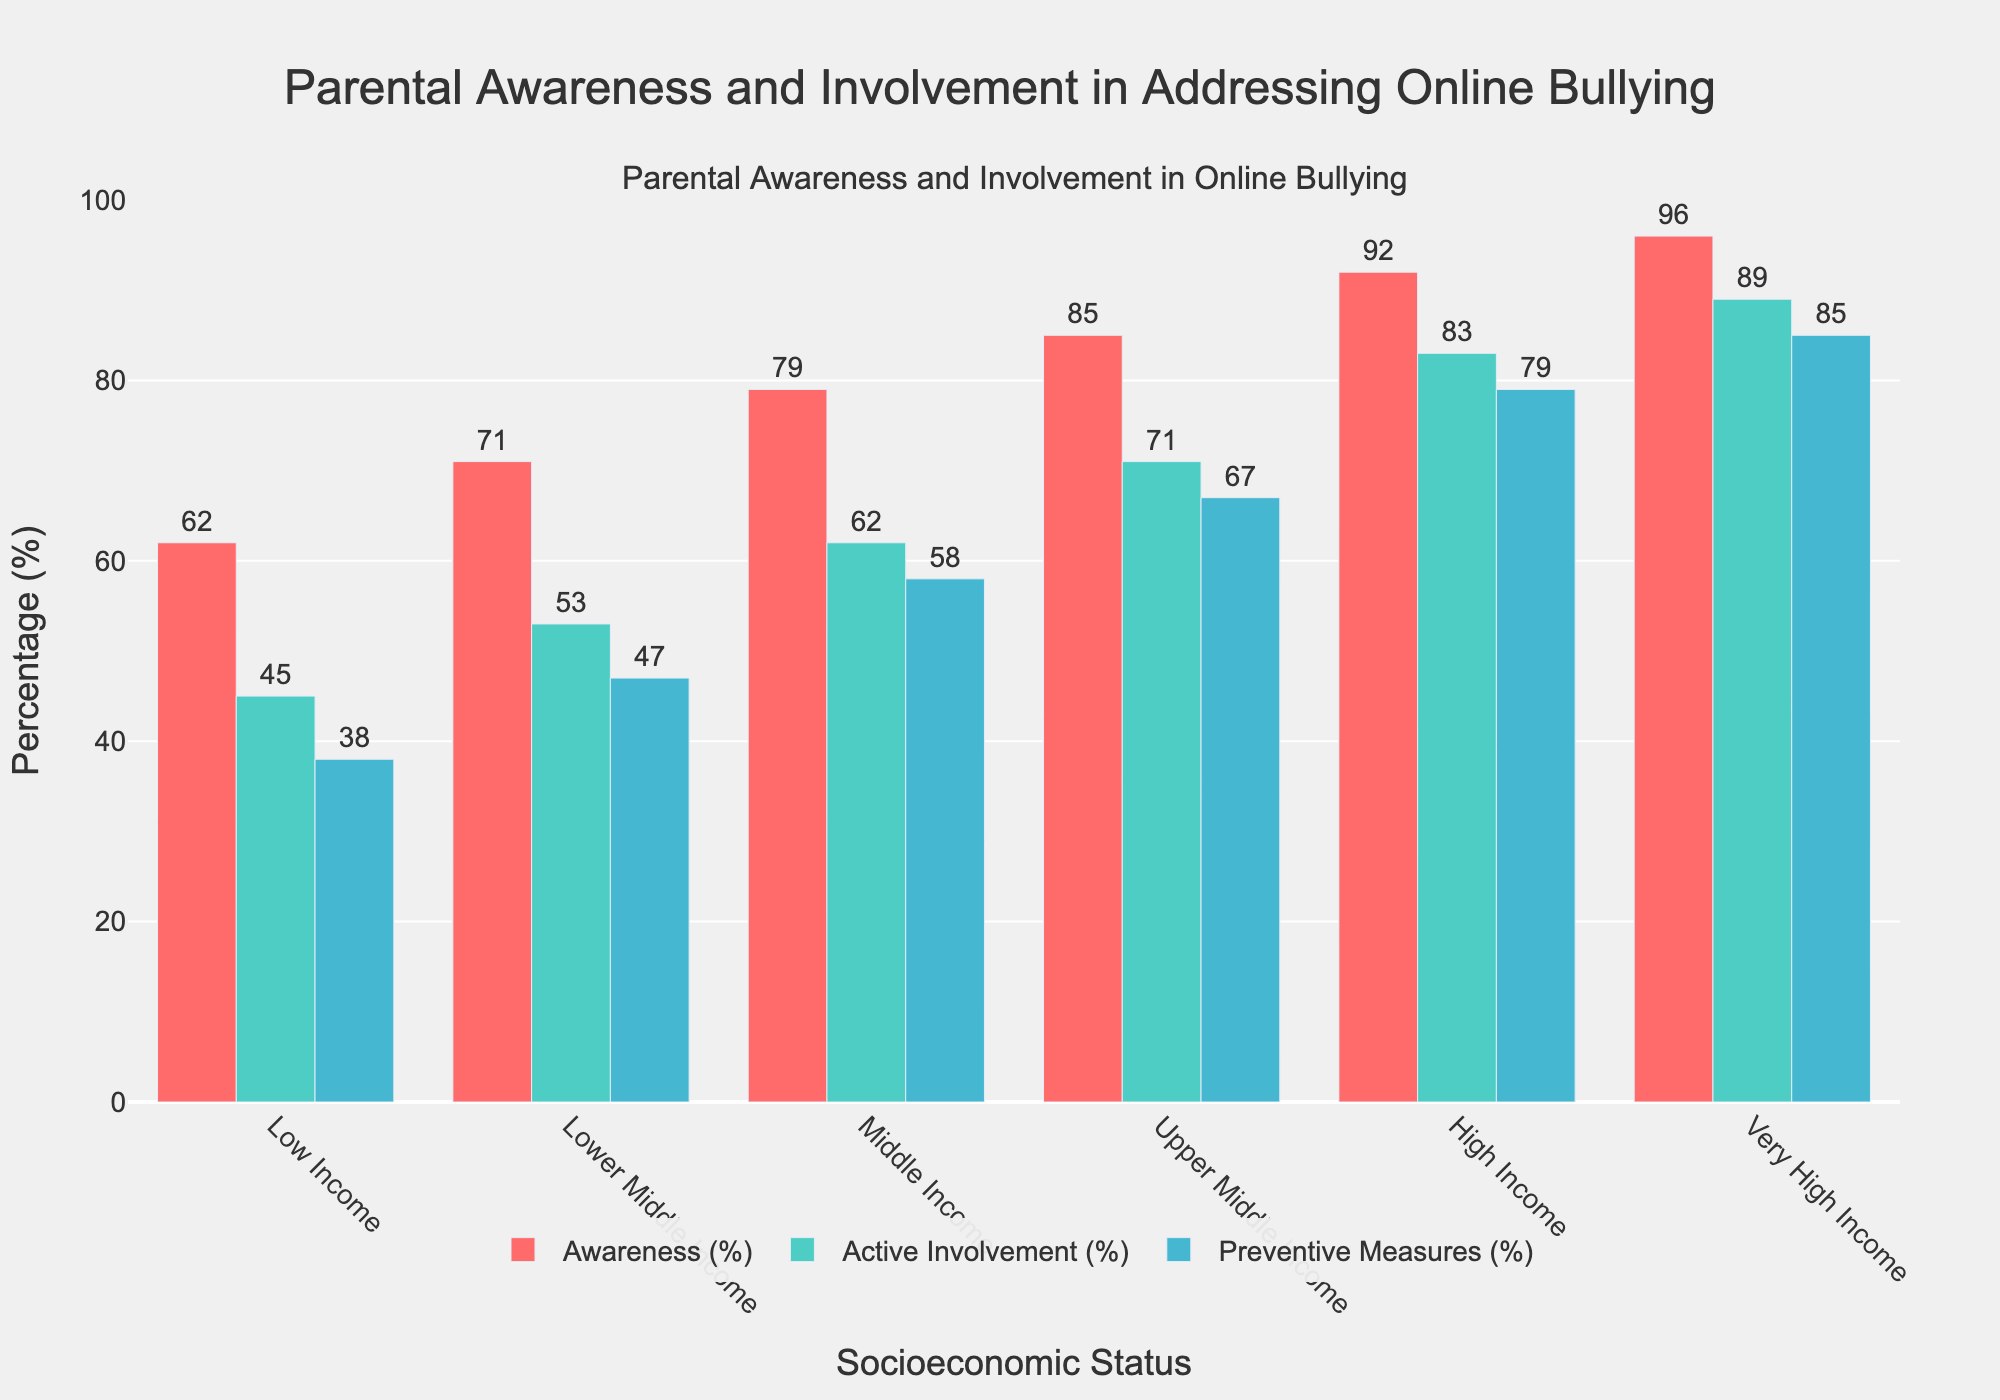What's the percentage difference in parental awareness between Middle Income and High Income groups? The percentage for Middle Income is 79%, and for High Income, it is 92%. The difference is 92% - 79% = 13%.
Answer: 13% Which socioeconomic status group shows the highest level of active involvement? The bars for Active Involvement (%) indicate that the Very High Income group has the highest value at 89%.
Answer: Very High Income Between which two neighboring socioeconomic statuses is the increase in preventive measures percentage the most significant? By observing the heights of the bars for Preventive Measures (%), the largest increase occurs between Upper Middle Income (67%) and High Income (79%), which is a difference of 12%.
Answer: Upper Middle Income to High Income Compare the trends in awareness and preventive measures percentages. Are there any socioeconomic status groups where awareness is significantly higher than preventive measures? Observing the chart, the awareness percentages are higher than preventive measures for all groups. However, the difference is most significant for lower socioeconomic groups like Low Income (62% Awareness and 38% Preventive Measures, a 24% difference) and Lower Middle Income (71% Awareness and 47% Preventive Measures, a 24% difference).
Answer: All groups; most significant in Low Income and Lower Middle Income What is the combined value of active involvement and preventive measures for the Upper Middle Income group? The active involvement percentage for Upper Middle Income is 71%, and for preventive measures, it is 67%. The combined value is 71% + 67% = 138%.
Answer: 138% How does parental awareness in Low Income compare to Very High Income groups? Awareness in Low Income is 62%, while in Very High Income, it is 96%. Comparing these, awareness is lower in Low Income by 96% - 62% = 34%.
Answer: Lower by 34% What is the average percentage of parental preventive measures across all socioeconomic statuses? Adding up the percentages for preventive measures (38 + 47 + 58 + 67 + 79 + 85) = 374. There are 6 groups, so the average is 374 / 6 ≈ 62.33%.
Answer: 62.33% Which group has the smallest difference between active involvement and preventive measures? For each group, calculate the difference:
- Low Income: 45% - 38% = 7%
- Lower Middle Income: 53% - 47% = 6%
- Middle Income: 62% - 58% = 4%
- Upper Middle Income: 71% - 67% = 4%
- High Income: 83% - 79% = 4%
- Very High Income: 89% - 85% = 4%
The smallest differences are in Middle Income, Upper Middle Income, High Income, and Very High Income, all with a difference of 4%.
Answer: Middle Income, Upper Middle Income, High Income, Very High Income (all 4%) 